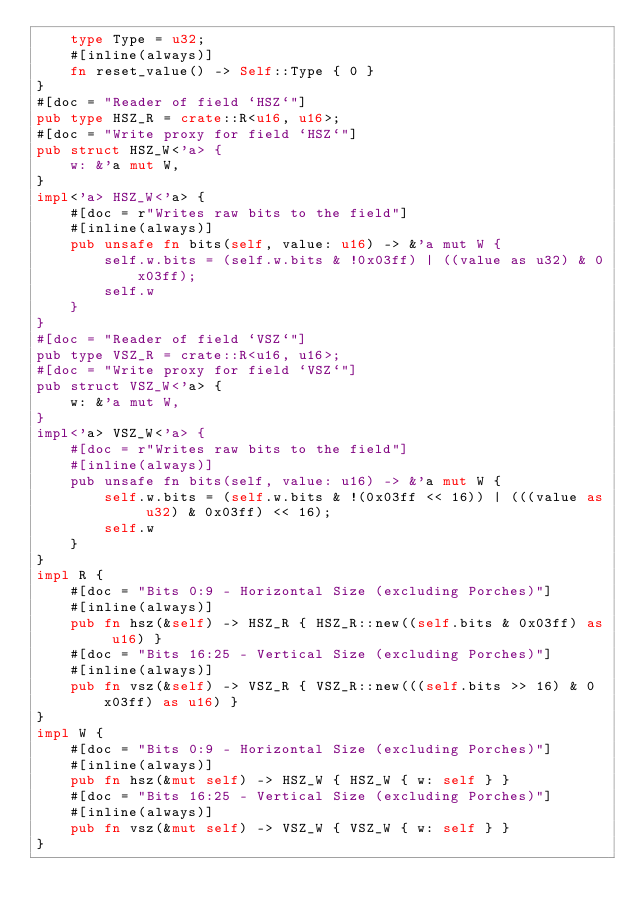Convert code to text. <code><loc_0><loc_0><loc_500><loc_500><_Rust_>    type Type = u32;
    #[inline(always)]
    fn reset_value() -> Self::Type { 0 }
}
#[doc = "Reader of field `HSZ`"]
pub type HSZ_R = crate::R<u16, u16>;
#[doc = "Write proxy for field `HSZ`"]
pub struct HSZ_W<'a> {
    w: &'a mut W,
}
impl<'a> HSZ_W<'a> {
    #[doc = r"Writes raw bits to the field"]
    #[inline(always)]
    pub unsafe fn bits(self, value: u16) -> &'a mut W {
        self.w.bits = (self.w.bits & !0x03ff) | ((value as u32) & 0x03ff);
        self.w
    }
}
#[doc = "Reader of field `VSZ`"]
pub type VSZ_R = crate::R<u16, u16>;
#[doc = "Write proxy for field `VSZ`"]
pub struct VSZ_W<'a> {
    w: &'a mut W,
}
impl<'a> VSZ_W<'a> {
    #[doc = r"Writes raw bits to the field"]
    #[inline(always)]
    pub unsafe fn bits(self, value: u16) -> &'a mut W {
        self.w.bits = (self.w.bits & !(0x03ff << 16)) | (((value as u32) & 0x03ff) << 16);
        self.w
    }
}
impl R {
    #[doc = "Bits 0:9 - Horizontal Size (excluding Porches)"]
    #[inline(always)]
    pub fn hsz(&self) -> HSZ_R { HSZ_R::new((self.bits & 0x03ff) as u16) }
    #[doc = "Bits 16:25 - Vertical Size (excluding Porches)"]
    #[inline(always)]
    pub fn vsz(&self) -> VSZ_R { VSZ_R::new(((self.bits >> 16) & 0x03ff) as u16) }
}
impl W {
    #[doc = "Bits 0:9 - Horizontal Size (excluding Porches)"]
    #[inline(always)]
    pub fn hsz(&mut self) -> HSZ_W { HSZ_W { w: self } }
    #[doc = "Bits 16:25 - Vertical Size (excluding Porches)"]
    #[inline(always)]
    pub fn vsz(&mut self) -> VSZ_W { VSZ_W { w: self } }
}
</code> 